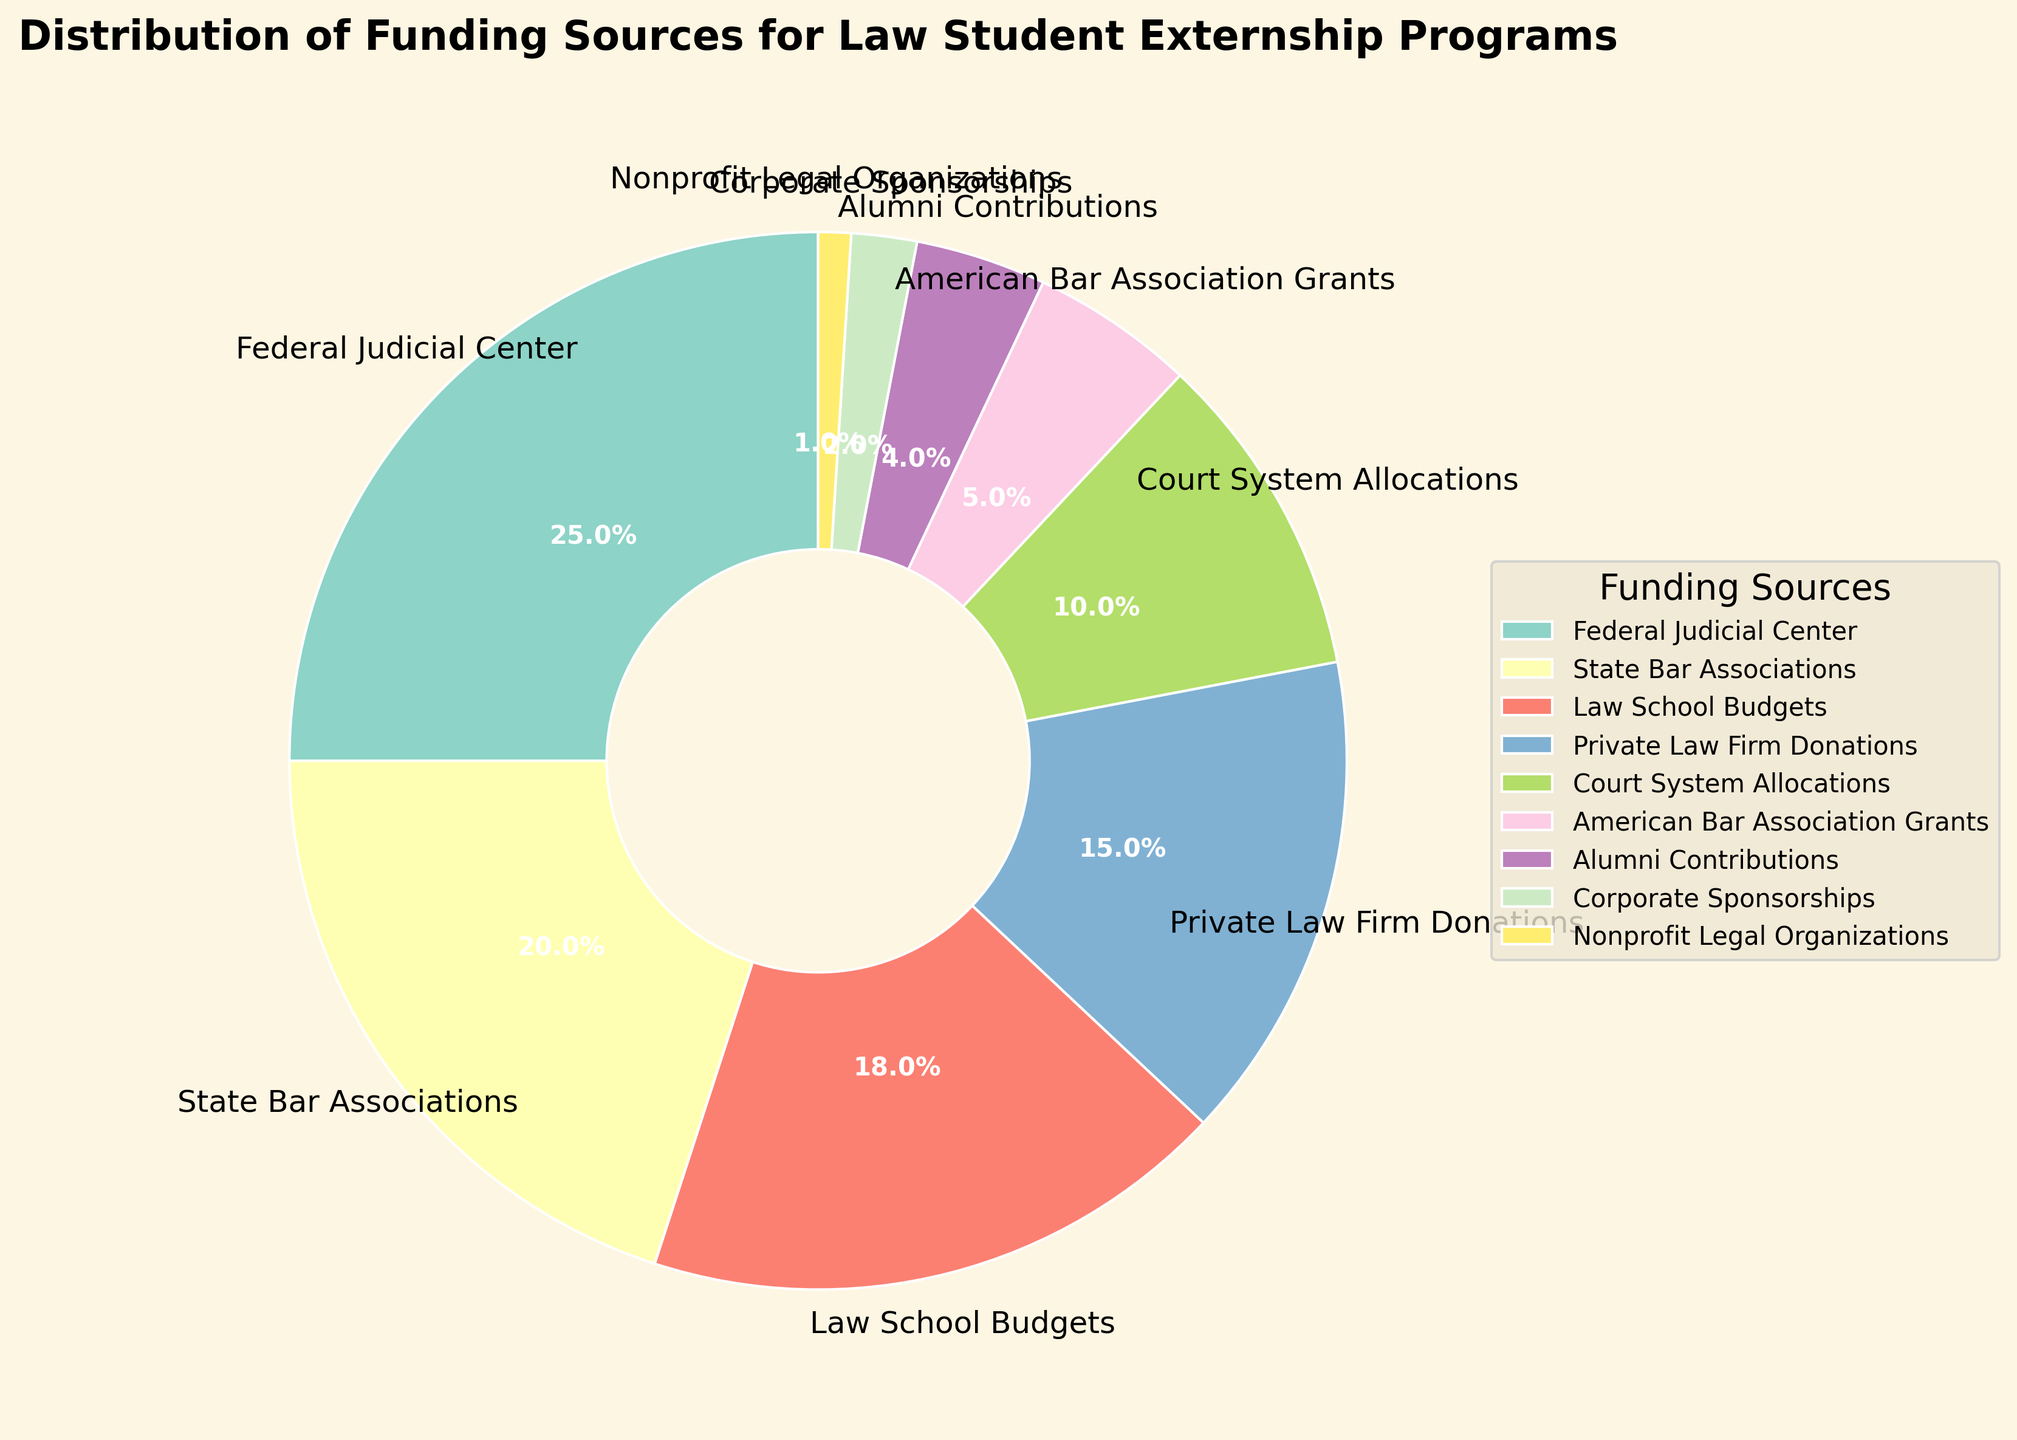What's the largest source of funding? The largest wedge in the pie chart represents the Federal Judicial Center, which accounts for 25% of the total funding. Therefore, the Federal Judicial Center is the largest source.
Answer: Federal Judicial Center How much more funding does the Federal Judicial Center provide compared to Corporate Sponsorships? The Federal Judicial Center contributes 25% while Corporate Sponsorships contribute 2%. The difference between them is 25% - 2% = 23%.
Answer: 23% Which funding source contributes the least? The smallest wedge in the pie chart represents Nonprofit Legal Organizations, which accounts for 1% of the total funding.
Answer: Nonprofit Legal Organizations What is the combined percentage of funding provided by Private Law Firm Donations and Court System Allocations? Private Law Firm Donations contribute 15% and Court System Allocations contribute 10%. Their combined contribution is 15% + 10% = 25%.
Answer: 25% How does the percentage of funding from Law School Budgets compare to that from State Bar Associations? Law School Budgets contribute 18%, while State Bar Associations contribute 20%. Therefore, State Bar Associations provide 2% more funding than Law School Budgets.
Answer: State Bar Associations provide 2% more What's the total percentage of funding from sources associated with the legal industry (State Bar Associations, Private Law Firm Donations, and American Bar Association Grants)? State Bar Associations contribute 20%, Private Law Firm Donations contribute 15%, and American Bar Association Grants contribute 5%. Their total contribution is 20% + 15% + 5% = 40%.
Answer: 40% If we exclude the Federal Judicial Center, which funding source provides the next highest percentage of funding? After excluding the Federal Judicial Center (25%), the next highest is State Bar Associations, contributing 20% of the total funding.
Answer: State Bar Associations Which funding sources each provide less than 5% of the total funding? The wedges representing Alumni Contributions (4%), Corporate Sponsorships (2%), and Nonprofit Legal Organizations (1%) each contribute less than 5% of the total funding.
Answer: Alumni Contributions, Corporate Sponsorships, Nonprofit Legal Organizations What is the difference in funding between Law School Budgets and the total percentage from Corporate Sponsorships, Nonprofit Legal Organizations, and Alumni Contributions? Law School Budgets contribute 18%. The combined contribution from Corporate Sponsorships, Nonprofit Legal Organizations, and Alumni Contributions is 2% + 1% + 4% = 7%. The difference is 18% - 7% = 11%.
Answer: 11% Which segments are visually the same size in the chart? Visually, none of the segments appear exactly the same size, but State Bar Associations (20%) and Law School Budgets (18%) are quite close, and less noticeable differences might be observed in small segments like Corporate Sponsorships (2%) and Nonprofit Legal Organizations (1%).
Answer: Not exactly the same, but close: State Bar Associations, Law School Budgets 